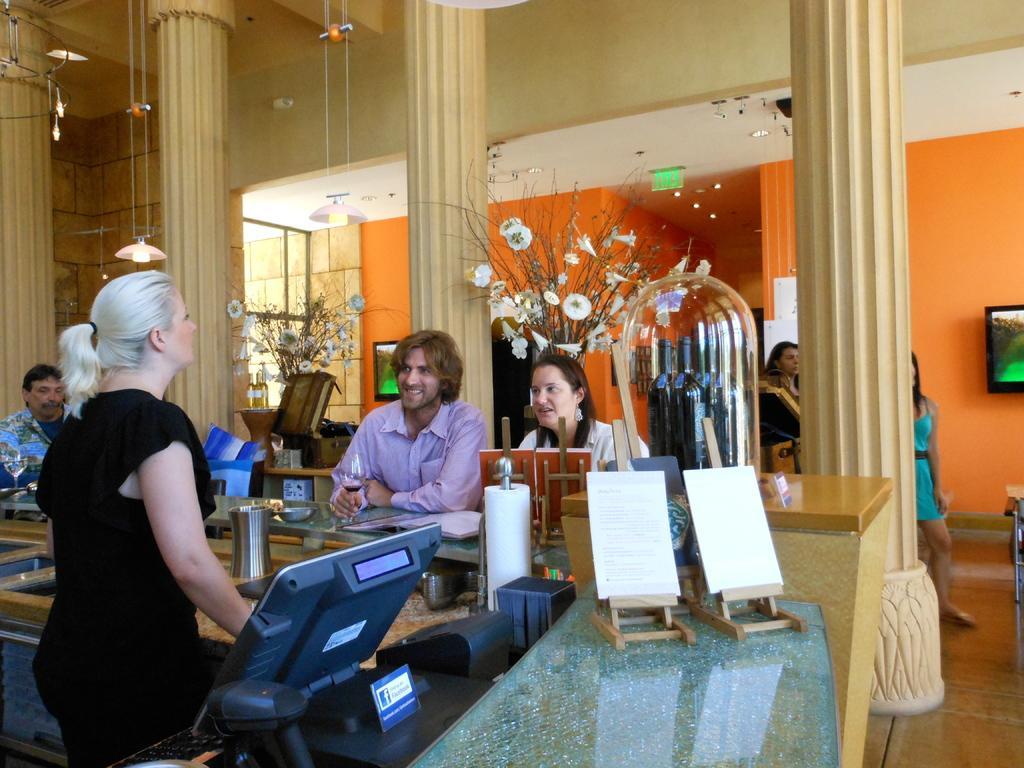How would you summarize this image in a sentence or two? In this image there is a person standing. In front of her there is a table. On top of it there is a computer and a few other objects. There are glasses and some other objects on the platform. Behind the platform, there are people standing on the floor. There are tables. On top of it there are flower pots. There are pillars. There are monitors and some other objects on the wall. On top of the image there are lights. There are lamps hanging from the rooftop. On the right side of the image there is some object. 